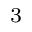Convert formula to latex. <formula><loc_0><loc_0><loc_500><loc_500>^ { 3 }</formula> 